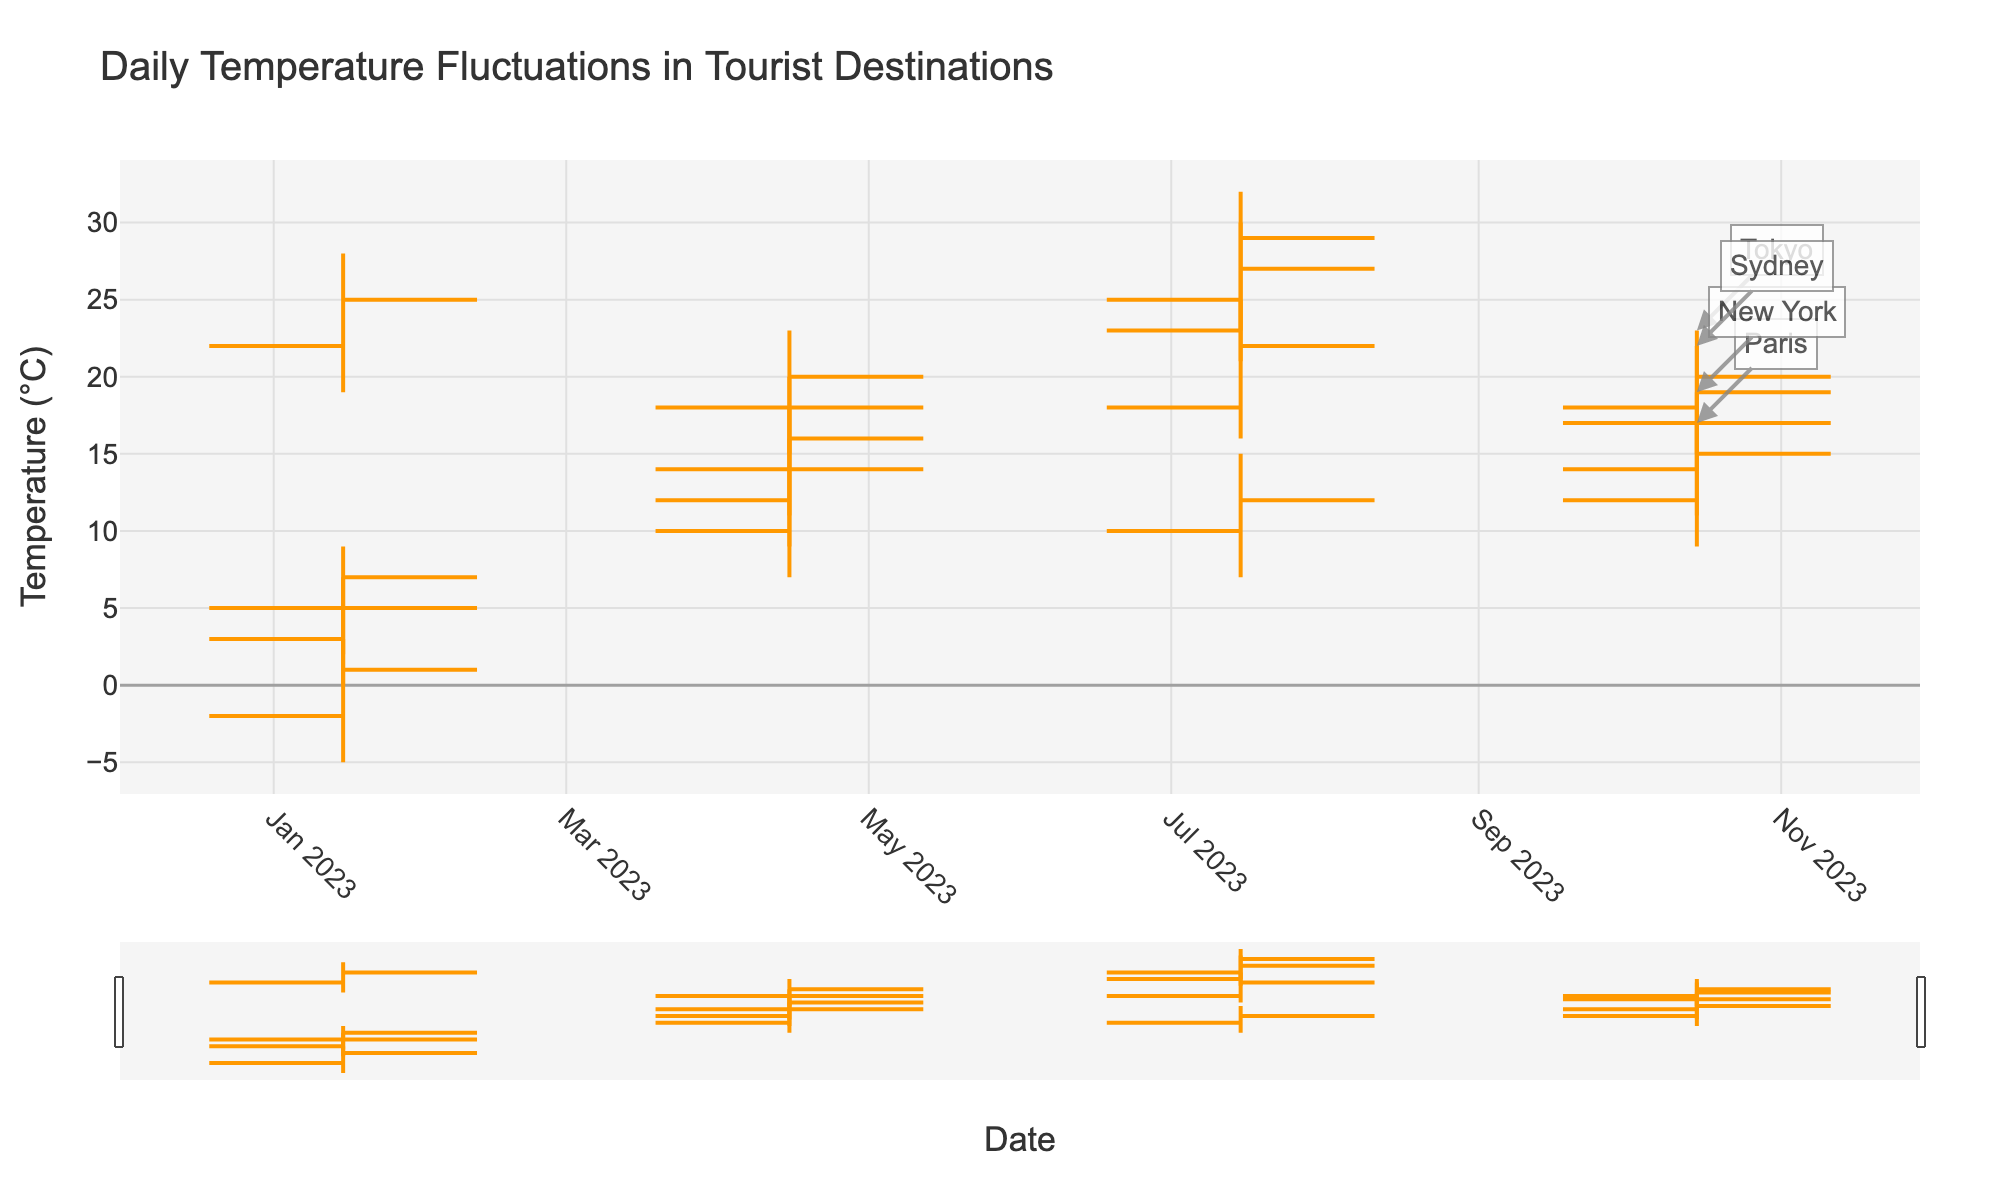what is the title of the figure? The title of the figure is at the top of the chart, providing a clear description of what the chart represents.
Answer: Daily Temperature Fluctuations in Tourist Destinations What is the temperature range for Paris in Winter? For Paris in Winter, the data shows the low temperature is 0°C and the high temperature is 7°C. This gives a range of 7 - 0 = 7°C.
Answer: 0°C to 7°C Which destination has the highest temperature during Summer? By observing the high temperatures for each destination during Summer, Tokyo has the highest recorded temperature at 32°C.
Answer: Tokyo What is the average closing temperature for New York across all seasons shown? The closing temperatures for New York are: Winter (1°C), Spring (16°C), Summer (27°C), and Fall (17°C). Adding these (1 + 16 + 27 + 17) = 61°C and dividing by 4 seasons gives the average as 61 / 4 = 15.25°C.
Answer: 15.25°C How does the temperature fluctuation in Sydney during Winter compare to that in Tokyo during Summer? Sydney's Winter temperatures fluctuate between 7°C (low) and 15°C (high), a range of 8°C. Tokyo's Summer temperatures fluctuate between 23°C (low) and 32°C (high), a range of 9°C. Comparing the ranges, Tokyo's fluctuation is 1°C greater than Sydney's.
Answer: Tokyo has a 1°C greater fluctuation In which season does Tokyo experience the greatest temperature fluctuation? Tokyo's temperature fluctuations are: Winter (7-2=5°C), Spring (20-11=9°C), Summer (32-23=9°C), Fall (23-15=8°C). Therefore, Spring and Summer both have the greatest fluctuation at 9°C each.
Answer: Spring and Summer What is the overall trend of temperatures in Sydney across the seasons? Observing the trend of low and high temperatures in Sydney, we see: Summer (19-28°C), Fall (15-23°C), Winter (7-15°C), Spring (14-22°C). The trend is that temperatures decrease from Summer to Winter and then rise again in Spring.
Answer: Decreasing from Summer to Winter, rising in Spring 